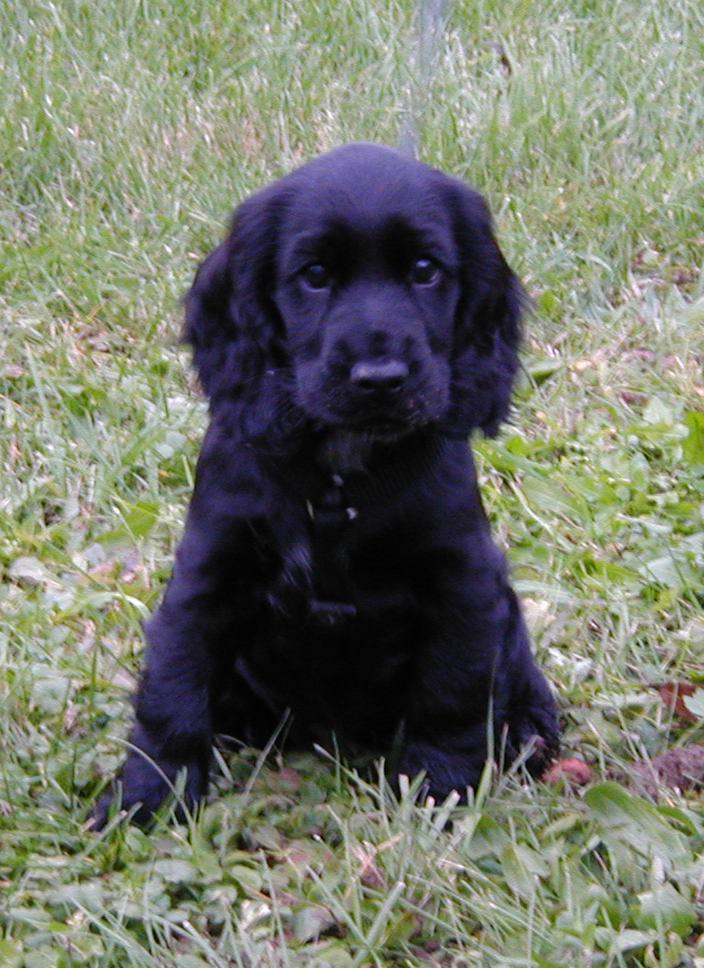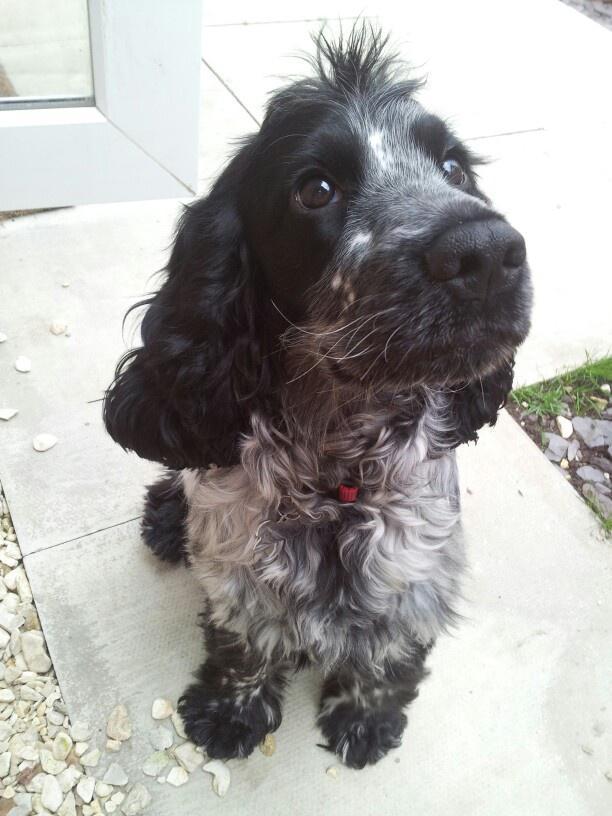The first image is the image on the left, the second image is the image on the right. Considering the images on both sides, is "One dark puppy is standing, and the other dark puppy is reclining." valid? Answer yes or no. No. The first image is the image on the left, the second image is the image on the right. Given the left and right images, does the statement "A single dog is posed on grass in the left image." hold true? Answer yes or no. Yes. 